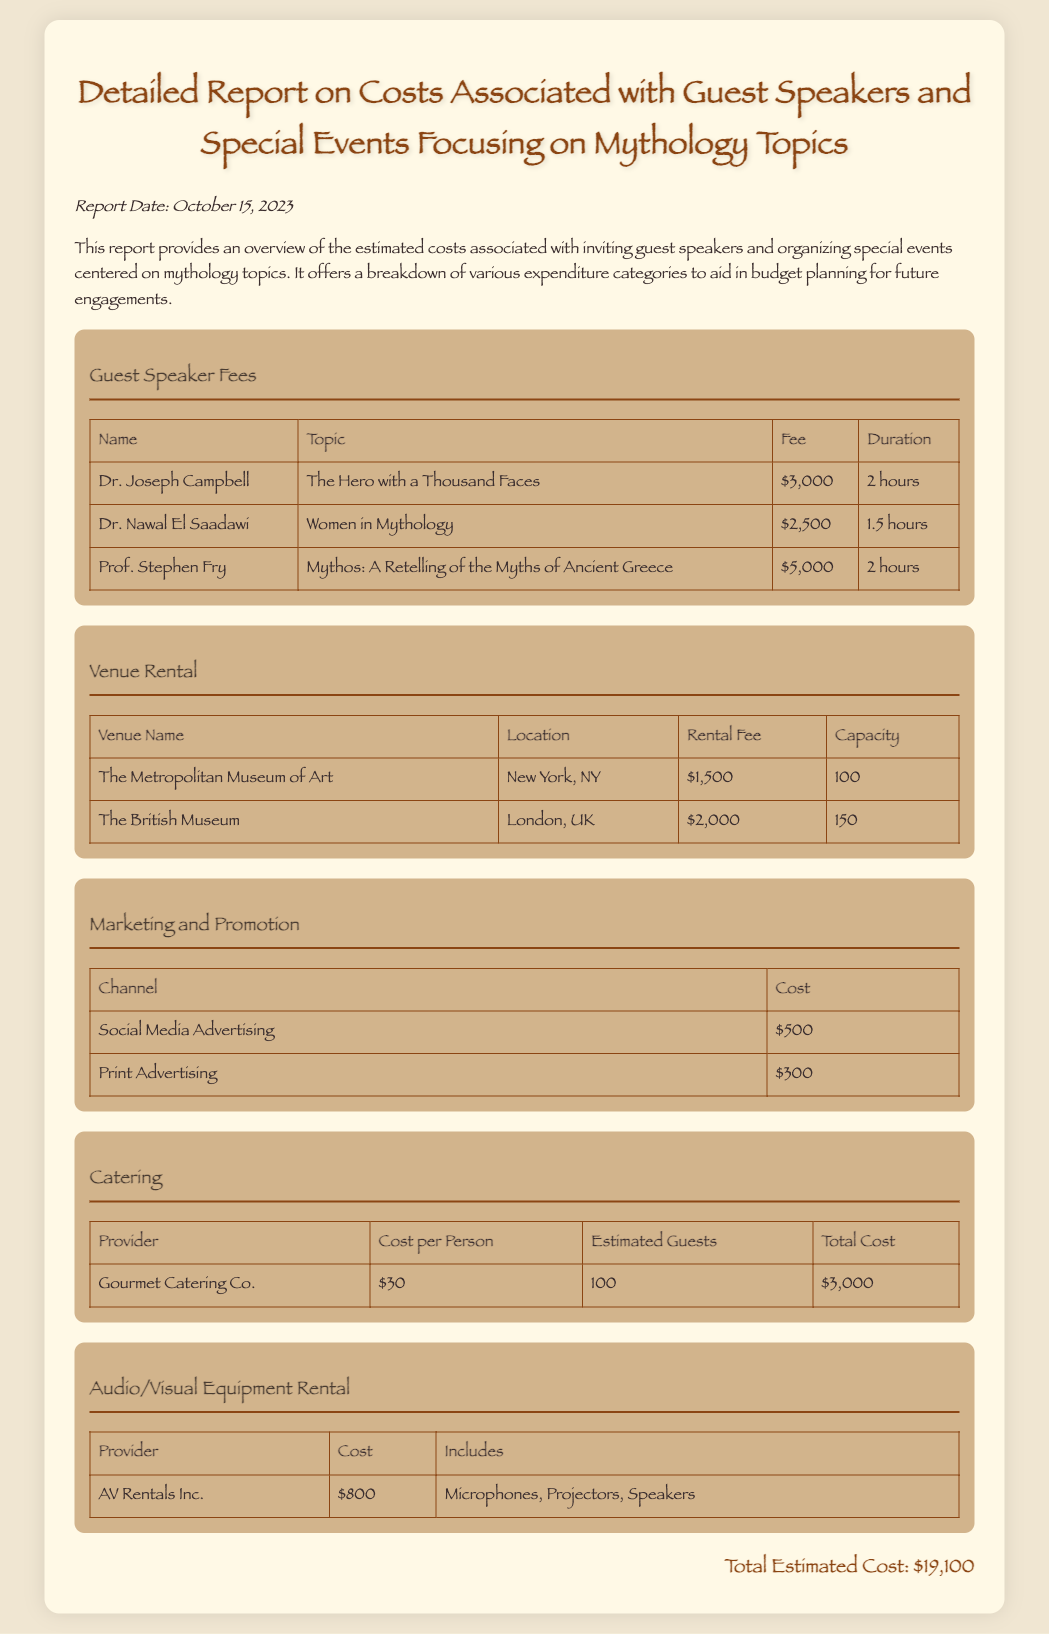What is the title of the report? The title is clearly stated at the beginning of the document as "Detailed Report on Costs Associated with Guest Speakers and Special Events Focusing on Mythology Topics."
Answer: Detailed Report on Costs Associated with Guest Speakers and Special Events Focusing on Mythology Topics Who is the guest speaker discussing "Women in Mythology"? The document lists the speaker for "Women in Mythology."
Answer: Dr. Nawal El Saadawi What is the rental fee for The British Museum? This information can be found in the Venue Rental section of the report, which lists rental fees for different venues.
Answer: $2,000 How many guests are estimated for catering? This information is specified under the Catering section regarding guest estimates.
Answer: 100 What is the total estimated cost for the event? The total estimated cost summarizes all expenses listed in the report.
Answer: $19,100 Which audio/visual equipment provider is mentioned? The document lists the provider for audio/visual equipment under the corresponding section.
Answer: AV Rentals Inc What is the fee for Prof. Stephen Fry? The fee for each guest speaker is listed in the Guest Speaker Fees section.
Answer: $5,000 What is the cost of social media advertising? The cost of social media advertising can be found in the Marketing and Promotion section of the report.
Answer: $500 What is the duration of Dr. Joseph Campbell's talk? The duration of each speaker's talk is provided in the Guest Speaker Fees section.
Answer: 2 hours 